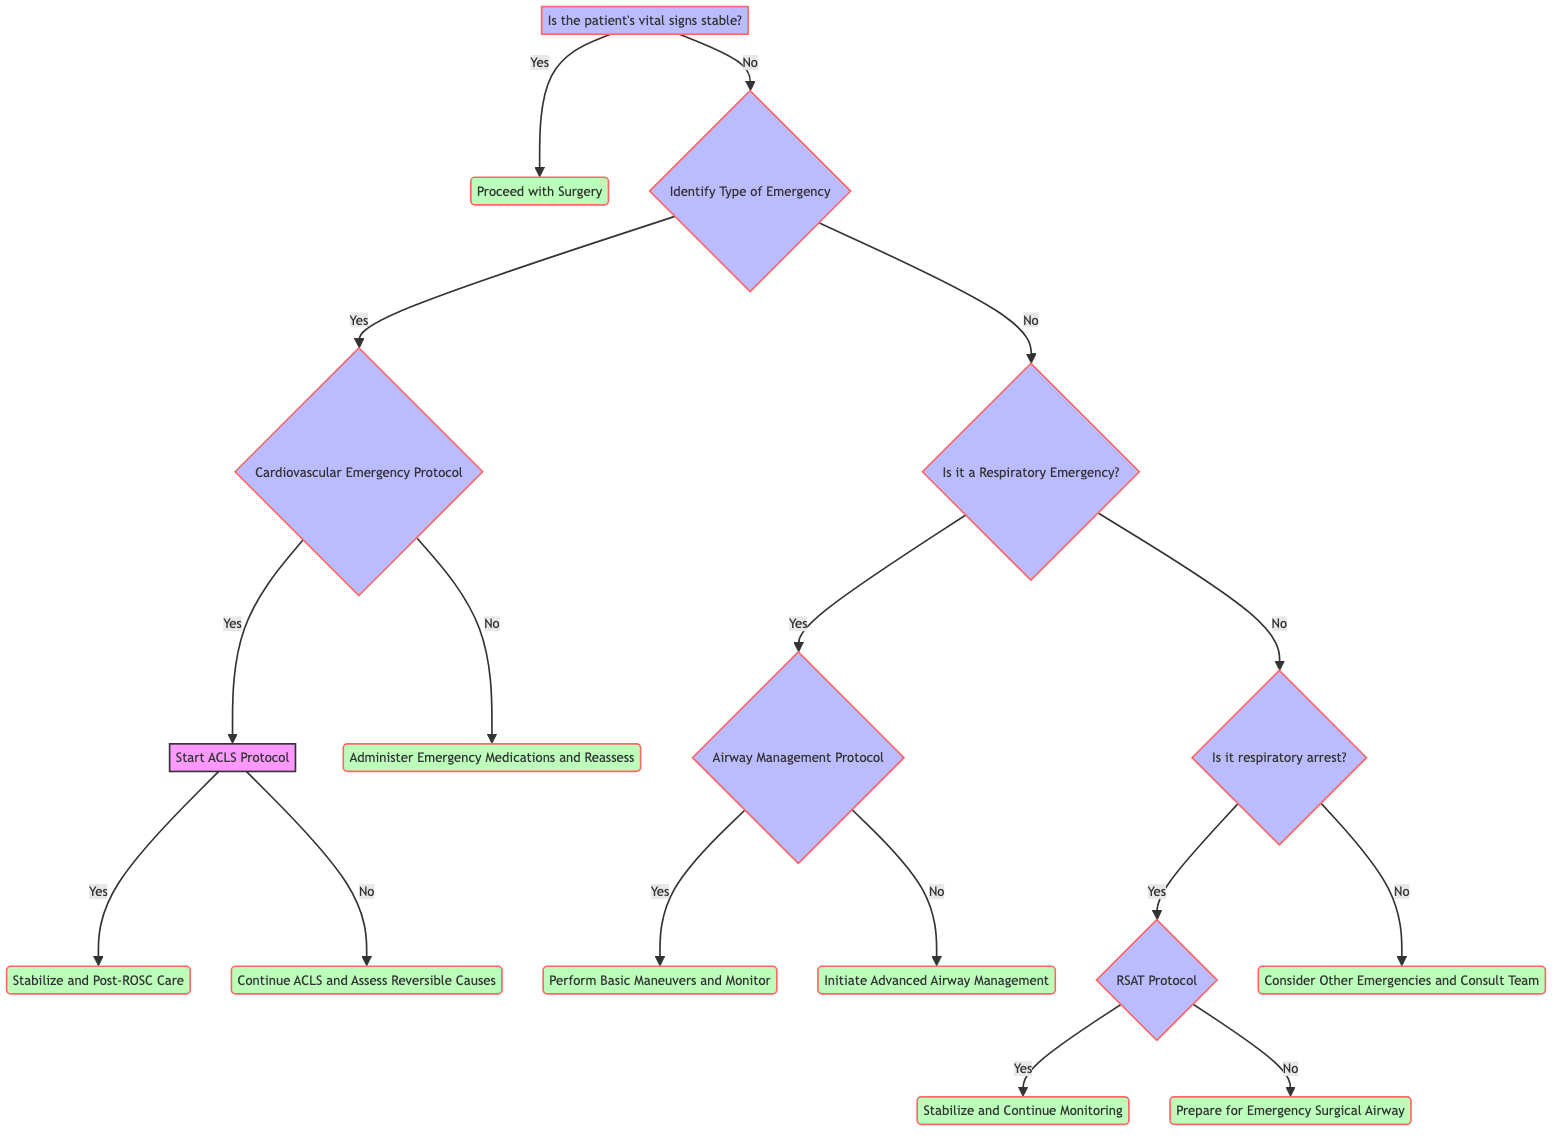Is the first step in the decision tree checking the patient's vital signs? The first question in the decision tree is "Is the patient's vital signs stable?" which indicates that checking the patient's vital signs is indeed the first step.
Answer: Yes How many options are there after identifying the type of emergency? After identifying the type of emergency, there are two main options: it could be a Cardiovascular Emergency or a Respiratory Emergency, leading to a total of two branches stemming from that decision point.
Answer: Two What happens if there is a cardiac arrest? If the decision tree indicates that there is a cardiac arrest within the Cardiovascular Emergency Protocol, the next action is to "Start ACLS Protocol."
Answer: Start ACLS Protocol What should be done if there is an airway obstruction? If it is identified that there is an airway obstruction, the protocol states to implement the "Airway Management Protocol."
Answer: Airway Management Protocol What is the outcome if the patient's breathing is restored in the RSAT Protocol? If the patient's breathing is restored during the RSAT Protocol, the next step is to "Stabilize and Continue Monitoring."
Answer: Stabilize and Continue Monitoring If the patient's vital signs are stable, what is the next step? When the patient's vital signs are stable, the decision directs to "Proceed with Surgery," indicating that surgery can continue without complications.
Answer: Proceed with Surgery If a respiratory arrest is not present, what should the team consider? If there is no respiratory arrest identified, the recommendation is to "Consider Other Emergencies and Consult Team," pointing to the necessity of evaluating other potential issues.
Answer: Consider Other Emergencies and Consult Team How does the diagram address situations where ROSC is not achieved after ACLS? If Return of Spontaneous Circulation (ROSC) is not achieved after implementing ACLS, the protocol advises to "Continue ACLS and Assess Reversible Causes," which indicates ongoing resuscitative efforts and investigations.
Answer: Continue ACLS and Assess Reversible Causes Is airway management necessary if basic maneuvers resolve the obstruction? If the obstruction can be resolved with basic maneuvers during the Airway Management Protocol, it indicates that further advanced airway management is not required at that moment.
Answer: No 